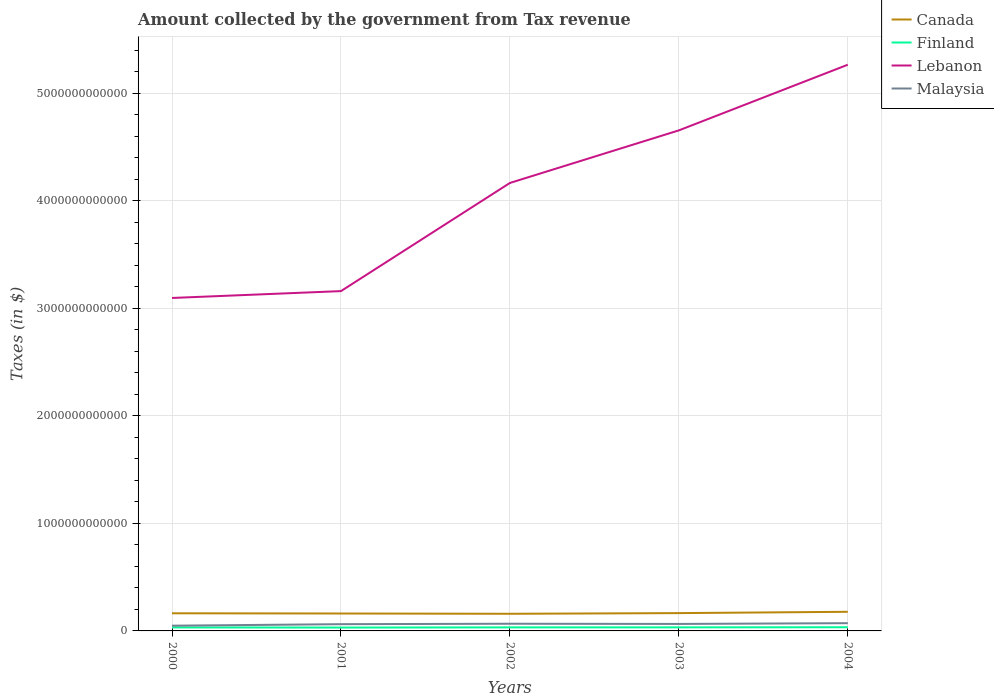Across all years, what is the maximum amount collected by the government from tax revenue in Malaysia?
Provide a succinct answer. 4.87e+1. In which year was the amount collected by the government from tax revenue in Lebanon maximum?
Provide a succinct answer. 2000. What is the total amount collected by the government from tax revenue in Malaysia in the graph?
Provide a succinct answer. -4.12e+09. What is the difference between the highest and the second highest amount collected by the government from tax revenue in Finland?
Offer a terse response. 3.12e+09. How many lines are there?
Offer a terse response. 4. What is the difference between two consecutive major ticks on the Y-axis?
Make the answer very short. 1.00e+12. Does the graph contain any zero values?
Make the answer very short. No. How many legend labels are there?
Provide a succinct answer. 4. What is the title of the graph?
Your answer should be compact. Amount collected by the government from Tax revenue. What is the label or title of the Y-axis?
Ensure brevity in your answer.  Taxes (in $). What is the Taxes (in $) in Canada in 2000?
Provide a succinct answer. 1.64e+11. What is the Taxes (in $) in Finland in 2000?
Offer a very short reply. 3.26e+1. What is the Taxes (in $) in Lebanon in 2000?
Your response must be concise. 3.10e+12. What is the Taxes (in $) in Malaysia in 2000?
Provide a succinct answer. 4.87e+1. What is the Taxes (in $) of Canada in 2001?
Keep it short and to the point. 1.62e+11. What is the Taxes (in $) of Finland in 2001?
Offer a very short reply. 3.12e+1. What is the Taxes (in $) in Lebanon in 2001?
Provide a succinct answer. 3.16e+12. What is the Taxes (in $) of Malaysia in 2001?
Offer a very short reply. 6.27e+1. What is the Taxes (in $) of Canada in 2002?
Your answer should be very brief. 1.59e+11. What is the Taxes (in $) of Finland in 2002?
Your answer should be compact. 3.30e+1. What is the Taxes (in $) in Lebanon in 2002?
Make the answer very short. 4.17e+12. What is the Taxes (in $) of Malaysia in 2002?
Your answer should be very brief. 6.69e+1. What is the Taxes (in $) of Canada in 2003?
Your answer should be very brief. 1.66e+11. What is the Taxes (in $) of Finland in 2003?
Provide a succinct answer. 3.31e+1. What is the Taxes (in $) of Lebanon in 2003?
Give a very brief answer. 4.66e+12. What is the Taxes (in $) in Malaysia in 2003?
Offer a very short reply. 6.49e+1. What is the Taxes (in $) in Canada in 2004?
Make the answer very short. 1.78e+11. What is the Taxes (in $) of Finland in 2004?
Make the answer very short. 3.43e+1. What is the Taxes (in $) of Lebanon in 2004?
Offer a very short reply. 5.27e+12. What is the Taxes (in $) in Malaysia in 2004?
Make the answer very short. 7.21e+1. Across all years, what is the maximum Taxes (in $) in Canada?
Your response must be concise. 1.78e+11. Across all years, what is the maximum Taxes (in $) in Finland?
Ensure brevity in your answer.  3.43e+1. Across all years, what is the maximum Taxes (in $) in Lebanon?
Provide a short and direct response. 5.27e+12. Across all years, what is the maximum Taxes (in $) in Malaysia?
Your answer should be very brief. 7.21e+1. Across all years, what is the minimum Taxes (in $) of Canada?
Keep it short and to the point. 1.59e+11. Across all years, what is the minimum Taxes (in $) of Finland?
Ensure brevity in your answer.  3.12e+1. Across all years, what is the minimum Taxes (in $) of Lebanon?
Provide a succinct answer. 3.10e+12. Across all years, what is the minimum Taxes (in $) in Malaysia?
Offer a very short reply. 4.87e+1. What is the total Taxes (in $) in Canada in the graph?
Your answer should be compact. 8.29e+11. What is the total Taxes (in $) in Finland in the graph?
Provide a short and direct response. 1.64e+11. What is the total Taxes (in $) in Lebanon in the graph?
Ensure brevity in your answer.  2.03e+13. What is the total Taxes (in $) in Malaysia in the graph?
Provide a short and direct response. 3.15e+11. What is the difference between the Taxes (in $) of Canada in 2000 and that in 2001?
Your response must be concise. 2.07e+09. What is the difference between the Taxes (in $) in Finland in 2000 and that in 2001?
Your answer should be compact. 1.37e+09. What is the difference between the Taxes (in $) in Lebanon in 2000 and that in 2001?
Give a very brief answer. -6.37e+1. What is the difference between the Taxes (in $) in Malaysia in 2000 and that in 2001?
Provide a succinct answer. -1.40e+1. What is the difference between the Taxes (in $) in Canada in 2000 and that in 2002?
Give a very brief answer. 4.74e+09. What is the difference between the Taxes (in $) in Finland in 2000 and that in 2002?
Your answer should be compact. -4.14e+08. What is the difference between the Taxes (in $) in Lebanon in 2000 and that in 2002?
Your answer should be very brief. -1.07e+12. What is the difference between the Taxes (in $) in Malaysia in 2000 and that in 2002?
Your answer should be compact. -1.82e+1. What is the difference between the Taxes (in $) in Canada in 2000 and that in 2003?
Your answer should be very brief. -1.55e+09. What is the difference between the Taxes (in $) in Finland in 2000 and that in 2003?
Make the answer very short. -5.11e+08. What is the difference between the Taxes (in $) of Lebanon in 2000 and that in 2003?
Make the answer very short. -1.56e+12. What is the difference between the Taxes (in $) in Malaysia in 2000 and that in 2003?
Provide a succinct answer. -1.62e+1. What is the difference between the Taxes (in $) of Canada in 2000 and that in 2004?
Your answer should be compact. -1.38e+1. What is the difference between the Taxes (in $) in Finland in 2000 and that in 2004?
Your answer should be very brief. -1.75e+09. What is the difference between the Taxes (in $) of Lebanon in 2000 and that in 2004?
Provide a succinct answer. -2.17e+12. What is the difference between the Taxes (in $) in Malaysia in 2000 and that in 2004?
Provide a succinct answer. -2.33e+1. What is the difference between the Taxes (in $) of Canada in 2001 and that in 2002?
Your answer should be very brief. 2.67e+09. What is the difference between the Taxes (in $) of Finland in 2001 and that in 2002?
Make the answer very short. -1.79e+09. What is the difference between the Taxes (in $) of Lebanon in 2001 and that in 2002?
Provide a short and direct response. -1.01e+12. What is the difference between the Taxes (in $) of Malaysia in 2001 and that in 2002?
Make the answer very short. -4.12e+09. What is the difference between the Taxes (in $) in Canada in 2001 and that in 2003?
Your answer should be compact. -3.62e+09. What is the difference between the Taxes (in $) of Finland in 2001 and that in 2003?
Offer a terse response. -1.88e+09. What is the difference between the Taxes (in $) of Lebanon in 2001 and that in 2003?
Offer a terse response. -1.49e+12. What is the difference between the Taxes (in $) in Malaysia in 2001 and that in 2003?
Your answer should be compact. -2.15e+09. What is the difference between the Taxes (in $) of Canada in 2001 and that in 2004?
Your answer should be very brief. -1.59e+1. What is the difference between the Taxes (in $) in Finland in 2001 and that in 2004?
Give a very brief answer. -3.12e+09. What is the difference between the Taxes (in $) in Lebanon in 2001 and that in 2004?
Ensure brevity in your answer.  -2.11e+12. What is the difference between the Taxes (in $) of Malaysia in 2001 and that in 2004?
Provide a short and direct response. -9.31e+09. What is the difference between the Taxes (in $) of Canada in 2002 and that in 2003?
Give a very brief answer. -6.29e+09. What is the difference between the Taxes (in $) in Finland in 2002 and that in 2003?
Provide a succinct answer. -9.70e+07. What is the difference between the Taxes (in $) in Lebanon in 2002 and that in 2003?
Your answer should be compact. -4.89e+11. What is the difference between the Taxes (in $) of Malaysia in 2002 and that in 2003?
Your answer should be compact. 1.97e+09. What is the difference between the Taxes (in $) of Canada in 2002 and that in 2004?
Give a very brief answer. -1.85e+1. What is the difference between the Taxes (in $) of Finland in 2002 and that in 2004?
Give a very brief answer. -1.34e+09. What is the difference between the Taxes (in $) in Lebanon in 2002 and that in 2004?
Keep it short and to the point. -1.10e+12. What is the difference between the Taxes (in $) of Malaysia in 2002 and that in 2004?
Give a very brief answer. -5.19e+09. What is the difference between the Taxes (in $) in Canada in 2003 and that in 2004?
Offer a very short reply. -1.22e+1. What is the difference between the Taxes (in $) of Finland in 2003 and that in 2004?
Keep it short and to the point. -1.24e+09. What is the difference between the Taxes (in $) in Lebanon in 2003 and that in 2004?
Your response must be concise. -6.11e+11. What is the difference between the Taxes (in $) of Malaysia in 2003 and that in 2004?
Your response must be concise. -7.16e+09. What is the difference between the Taxes (in $) in Canada in 2000 and the Taxes (in $) in Finland in 2001?
Offer a terse response. 1.33e+11. What is the difference between the Taxes (in $) in Canada in 2000 and the Taxes (in $) in Lebanon in 2001?
Offer a terse response. -3.00e+12. What is the difference between the Taxes (in $) in Canada in 2000 and the Taxes (in $) in Malaysia in 2001?
Offer a very short reply. 1.01e+11. What is the difference between the Taxes (in $) of Finland in 2000 and the Taxes (in $) of Lebanon in 2001?
Offer a very short reply. -3.13e+12. What is the difference between the Taxes (in $) of Finland in 2000 and the Taxes (in $) of Malaysia in 2001?
Your answer should be very brief. -3.02e+1. What is the difference between the Taxes (in $) in Lebanon in 2000 and the Taxes (in $) in Malaysia in 2001?
Provide a succinct answer. 3.03e+12. What is the difference between the Taxes (in $) of Canada in 2000 and the Taxes (in $) of Finland in 2002?
Provide a short and direct response. 1.31e+11. What is the difference between the Taxes (in $) of Canada in 2000 and the Taxes (in $) of Lebanon in 2002?
Provide a short and direct response. -4.00e+12. What is the difference between the Taxes (in $) of Canada in 2000 and the Taxes (in $) of Malaysia in 2002?
Offer a very short reply. 9.72e+1. What is the difference between the Taxes (in $) in Finland in 2000 and the Taxes (in $) in Lebanon in 2002?
Your answer should be compact. -4.13e+12. What is the difference between the Taxes (in $) in Finland in 2000 and the Taxes (in $) in Malaysia in 2002?
Your answer should be compact. -3.43e+1. What is the difference between the Taxes (in $) of Lebanon in 2000 and the Taxes (in $) of Malaysia in 2002?
Offer a terse response. 3.03e+12. What is the difference between the Taxes (in $) in Canada in 2000 and the Taxes (in $) in Finland in 2003?
Offer a very short reply. 1.31e+11. What is the difference between the Taxes (in $) of Canada in 2000 and the Taxes (in $) of Lebanon in 2003?
Make the answer very short. -4.49e+12. What is the difference between the Taxes (in $) of Canada in 2000 and the Taxes (in $) of Malaysia in 2003?
Offer a terse response. 9.92e+1. What is the difference between the Taxes (in $) in Finland in 2000 and the Taxes (in $) in Lebanon in 2003?
Offer a very short reply. -4.62e+12. What is the difference between the Taxes (in $) in Finland in 2000 and the Taxes (in $) in Malaysia in 2003?
Your answer should be compact. -3.23e+1. What is the difference between the Taxes (in $) in Lebanon in 2000 and the Taxes (in $) in Malaysia in 2003?
Offer a very short reply. 3.03e+12. What is the difference between the Taxes (in $) in Canada in 2000 and the Taxes (in $) in Finland in 2004?
Your response must be concise. 1.30e+11. What is the difference between the Taxes (in $) in Canada in 2000 and the Taxes (in $) in Lebanon in 2004?
Give a very brief answer. -5.10e+12. What is the difference between the Taxes (in $) of Canada in 2000 and the Taxes (in $) of Malaysia in 2004?
Offer a terse response. 9.20e+1. What is the difference between the Taxes (in $) in Finland in 2000 and the Taxes (in $) in Lebanon in 2004?
Keep it short and to the point. -5.23e+12. What is the difference between the Taxes (in $) in Finland in 2000 and the Taxes (in $) in Malaysia in 2004?
Provide a short and direct response. -3.95e+1. What is the difference between the Taxes (in $) of Lebanon in 2000 and the Taxes (in $) of Malaysia in 2004?
Keep it short and to the point. 3.02e+12. What is the difference between the Taxes (in $) of Canada in 2001 and the Taxes (in $) of Finland in 2002?
Provide a short and direct response. 1.29e+11. What is the difference between the Taxes (in $) in Canada in 2001 and the Taxes (in $) in Lebanon in 2002?
Your answer should be compact. -4.00e+12. What is the difference between the Taxes (in $) in Canada in 2001 and the Taxes (in $) in Malaysia in 2002?
Offer a terse response. 9.52e+1. What is the difference between the Taxes (in $) of Finland in 2001 and the Taxes (in $) of Lebanon in 2002?
Your answer should be very brief. -4.14e+12. What is the difference between the Taxes (in $) of Finland in 2001 and the Taxes (in $) of Malaysia in 2002?
Your answer should be compact. -3.56e+1. What is the difference between the Taxes (in $) of Lebanon in 2001 and the Taxes (in $) of Malaysia in 2002?
Ensure brevity in your answer.  3.09e+12. What is the difference between the Taxes (in $) of Canada in 2001 and the Taxes (in $) of Finland in 2003?
Keep it short and to the point. 1.29e+11. What is the difference between the Taxes (in $) in Canada in 2001 and the Taxes (in $) in Lebanon in 2003?
Make the answer very short. -4.49e+12. What is the difference between the Taxes (in $) in Canada in 2001 and the Taxes (in $) in Malaysia in 2003?
Keep it short and to the point. 9.71e+1. What is the difference between the Taxes (in $) of Finland in 2001 and the Taxes (in $) of Lebanon in 2003?
Make the answer very short. -4.62e+12. What is the difference between the Taxes (in $) in Finland in 2001 and the Taxes (in $) in Malaysia in 2003?
Give a very brief answer. -3.37e+1. What is the difference between the Taxes (in $) of Lebanon in 2001 and the Taxes (in $) of Malaysia in 2003?
Offer a very short reply. 3.10e+12. What is the difference between the Taxes (in $) of Canada in 2001 and the Taxes (in $) of Finland in 2004?
Make the answer very short. 1.28e+11. What is the difference between the Taxes (in $) of Canada in 2001 and the Taxes (in $) of Lebanon in 2004?
Ensure brevity in your answer.  -5.10e+12. What is the difference between the Taxes (in $) in Canada in 2001 and the Taxes (in $) in Malaysia in 2004?
Your answer should be very brief. 9.00e+1. What is the difference between the Taxes (in $) in Finland in 2001 and the Taxes (in $) in Lebanon in 2004?
Offer a terse response. -5.23e+12. What is the difference between the Taxes (in $) of Finland in 2001 and the Taxes (in $) of Malaysia in 2004?
Provide a succinct answer. -4.08e+1. What is the difference between the Taxes (in $) in Lebanon in 2001 and the Taxes (in $) in Malaysia in 2004?
Your answer should be very brief. 3.09e+12. What is the difference between the Taxes (in $) in Canada in 2002 and the Taxes (in $) in Finland in 2003?
Offer a very short reply. 1.26e+11. What is the difference between the Taxes (in $) of Canada in 2002 and the Taxes (in $) of Lebanon in 2003?
Keep it short and to the point. -4.50e+12. What is the difference between the Taxes (in $) of Canada in 2002 and the Taxes (in $) of Malaysia in 2003?
Provide a succinct answer. 9.45e+1. What is the difference between the Taxes (in $) of Finland in 2002 and the Taxes (in $) of Lebanon in 2003?
Your answer should be very brief. -4.62e+12. What is the difference between the Taxes (in $) in Finland in 2002 and the Taxes (in $) in Malaysia in 2003?
Keep it short and to the point. -3.19e+1. What is the difference between the Taxes (in $) in Lebanon in 2002 and the Taxes (in $) in Malaysia in 2003?
Keep it short and to the point. 4.10e+12. What is the difference between the Taxes (in $) in Canada in 2002 and the Taxes (in $) in Finland in 2004?
Provide a succinct answer. 1.25e+11. What is the difference between the Taxes (in $) in Canada in 2002 and the Taxes (in $) in Lebanon in 2004?
Offer a terse response. -5.11e+12. What is the difference between the Taxes (in $) in Canada in 2002 and the Taxes (in $) in Malaysia in 2004?
Provide a short and direct response. 8.73e+1. What is the difference between the Taxes (in $) of Finland in 2002 and the Taxes (in $) of Lebanon in 2004?
Make the answer very short. -5.23e+12. What is the difference between the Taxes (in $) of Finland in 2002 and the Taxes (in $) of Malaysia in 2004?
Your answer should be compact. -3.91e+1. What is the difference between the Taxes (in $) in Lebanon in 2002 and the Taxes (in $) in Malaysia in 2004?
Provide a short and direct response. 4.09e+12. What is the difference between the Taxes (in $) in Canada in 2003 and the Taxes (in $) in Finland in 2004?
Offer a terse response. 1.31e+11. What is the difference between the Taxes (in $) of Canada in 2003 and the Taxes (in $) of Lebanon in 2004?
Provide a succinct answer. -5.10e+12. What is the difference between the Taxes (in $) of Canada in 2003 and the Taxes (in $) of Malaysia in 2004?
Offer a terse response. 9.36e+1. What is the difference between the Taxes (in $) of Finland in 2003 and the Taxes (in $) of Lebanon in 2004?
Offer a very short reply. -5.23e+12. What is the difference between the Taxes (in $) of Finland in 2003 and the Taxes (in $) of Malaysia in 2004?
Your response must be concise. -3.90e+1. What is the difference between the Taxes (in $) in Lebanon in 2003 and the Taxes (in $) in Malaysia in 2004?
Your answer should be very brief. 4.58e+12. What is the average Taxes (in $) of Canada per year?
Your answer should be compact. 1.66e+11. What is the average Taxes (in $) in Finland per year?
Give a very brief answer. 3.28e+1. What is the average Taxes (in $) of Lebanon per year?
Provide a short and direct response. 4.07e+12. What is the average Taxes (in $) in Malaysia per year?
Your answer should be very brief. 6.31e+1. In the year 2000, what is the difference between the Taxes (in $) in Canada and Taxes (in $) in Finland?
Your response must be concise. 1.32e+11. In the year 2000, what is the difference between the Taxes (in $) of Canada and Taxes (in $) of Lebanon?
Provide a short and direct response. -2.93e+12. In the year 2000, what is the difference between the Taxes (in $) of Canada and Taxes (in $) of Malaysia?
Provide a succinct answer. 1.15e+11. In the year 2000, what is the difference between the Taxes (in $) in Finland and Taxes (in $) in Lebanon?
Give a very brief answer. -3.06e+12. In the year 2000, what is the difference between the Taxes (in $) of Finland and Taxes (in $) of Malaysia?
Your answer should be very brief. -1.61e+1. In the year 2000, what is the difference between the Taxes (in $) in Lebanon and Taxes (in $) in Malaysia?
Ensure brevity in your answer.  3.05e+12. In the year 2001, what is the difference between the Taxes (in $) in Canada and Taxes (in $) in Finland?
Your answer should be very brief. 1.31e+11. In the year 2001, what is the difference between the Taxes (in $) in Canada and Taxes (in $) in Lebanon?
Your answer should be very brief. -3.00e+12. In the year 2001, what is the difference between the Taxes (in $) in Canada and Taxes (in $) in Malaysia?
Your answer should be very brief. 9.93e+1. In the year 2001, what is the difference between the Taxes (in $) of Finland and Taxes (in $) of Lebanon?
Your answer should be compact. -3.13e+12. In the year 2001, what is the difference between the Taxes (in $) in Finland and Taxes (in $) in Malaysia?
Provide a succinct answer. -3.15e+1. In the year 2001, what is the difference between the Taxes (in $) of Lebanon and Taxes (in $) of Malaysia?
Provide a succinct answer. 3.10e+12. In the year 2002, what is the difference between the Taxes (in $) in Canada and Taxes (in $) in Finland?
Keep it short and to the point. 1.26e+11. In the year 2002, what is the difference between the Taxes (in $) in Canada and Taxes (in $) in Lebanon?
Offer a terse response. -4.01e+12. In the year 2002, what is the difference between the Taxes (in $) of Canada and Taxes (in $) of Malaysia?
Provide a succinct answer. 9.25e+1. In the year 2002, what is the difference between the Taxes (in $) in Finland and Taxes (in $) in Lebanon?
Provide a short and direct response. -4.13e+12. In the year 2002, what is the difference between the Taxes (in $) of Finland and Taxes (in $) of Malaysia?
Your answer should be compact. -3.39e+1. In the year 2002, what is the difference between the Taxes (in $) of Lebanon and Taxes (in $) of Malaysia?
Provide a short and direct response. 4.10e+12. In the year 2003, what is the difference between the Taxes (in $) in Canada and Taxes (in $) in Finland?
Provide a succinct answer. 1.33e+11. In the year 2003, what is the difference between the Taxes (in $) in Canada and Taxes (in $) in Lebanon?
Provide a succinct answer. -4.49e+12. In the year 2003, what is the difference between the Taxes (in $) of Canada and Taxes (in $) of Malaysia?
Give a very brief answer. 1.01e+11. In the year 2003, what is the difference between the Taxes (in $) of Finland and Taxes (in $) of Lebanon?
Offer a terse response. -4.62e+12. In the year 2003, what is the difference between the Taxes (in $) in Finland and Taxes (in $) in Malaysia?
Offer a terse response. -3.18e+1. In the year 2003, what is the difference between the Taxes (in $) in Lebanon and Taxes (in $) in Malaysia?
Give a very brief answer. 4.59e+12. In the year 2004, what is the difference between the Taxes (in $) in Canada and Taxes (in $) in Finland?
Offer a very short reply. 1.44e+11. In the year 2004, what is the difference between the Taxes (in $) in Canada and Taxes (in $) in Lebanon?
Provide a short and direct response. -5.09e+12. In the year 2004, what is the difference between the Taxes (in $) in Canada and Taxes (in $) in Malaysia?
Offer a very short reply. 1.06e+11. In the year 2004, what is the difference between the Taxes (in $) in Finland and Taxes (in $) in Lebanon?
Give a very brief answer. -5.23e+12. In the year 2004, what is the difference between the Taxes (in $) in Finland and Taxes (in $) in Malaysia?
Keep it short and to the point. -3.77e+1. In the year 2004, what is the difference between the Taxes (in $) in Lebanon and Taxes (in $) in Malaysia?
Offer a terse response. 5.19e+12. What is the ratio of the Taxes (in $) of Canada in 2000 to that in 2001?
Give a very brief answer. 1.01. What is the ratio of the Taxes (in $) in Finland in 2000 to that in 2001?
Keep it short and to the point. 1.04. What is the ratio of the Taxes (in $) in Lebanon in 2000 to that in 2001?
Keep it short and to the point. 0.98. What is the ratio of the Taxes (in $) in Malaysia in 2000 to that in 2001?
Offer a terse response. 0.78. What is the ratio of the Taxes (in $) of Canada in 2000 to that in 2002?
Your answer should be very brief. 1.03. What is the ratio of the Taxes (in $) in Finland in 2000 to that in 2002?
Your answer should be compact. 0.99. What is the ratio of the Taxes (in $) of Lebanon in 2000 to that in 2002?
Offer a very short reply. 0.74. What is the ratio of the Taxes (in $) of Malaysia in 2000 to that in 2002?
Keep it short and to the point. 0.73. What is the ratio of the Taxes (in $) of Canada in 2000 to that in 2003?
Keep it short and to the point. 0.99. What is the ratio of the Taxes (in $) in Finland in 2000 to that in 2003?
Offer a very short reply. 0.98. What is the ratio of the Taxes (in $) of Lebanon in 2000 to that in 2003?
Make the answer very short. 0.67. What is the ratio of the Taxes (in $) in Malaysia in 2000 to that in 2003?
Make the answer very short. 0.75. What is the ratio of the Taxes (in $) of Canada in 2000 to that in 2004?
Your answer should be very brief. 0.92. What is the ratio of the Taxes (in $) of Finland in 2000 to that in 2004?
Provide a succinct answer. 0.95. What is the ratio of the Taxes (in $) of Lebanon in 2000 to that in 2004?
Your answer should be very brief. 0.59. What is the ratio of the Taxes (in $) in Malaysia in 2000 to that in 2004?
Make the answer very short. 0.68. What is the ratio of the Taxes (in $) in Canada in 2001 to that in 2002?
Ensure brevity in your answer.  1.02. What is the ratio of the Taxes (in $) in Finland in 2001 to that in 2002?
Your answer should be compact. 0.95. What is the ratio of the Taxes (in $) of Lebanon in 2001 to that in 2002?
Keep it short and to the point. 0.76. What is the ratio of the Taxes (in $) in Malaysia in 2001 to that in 2002?
Make the answer very short. 0.94. What is the ratio of the Taxes (in $) of Canada in 2001 to that in 2003?
Your answer should be very brief. 0.98. What is the ratio of the Taxes (in $) in Finland in 2001 to that in 2003?
Your answer should be very brief. 0.94. What is the ratio of the Taxes (in $) of Lebanon in 2001 to that in 2003?
Offer a very short reply. 0.68. What is the ratio of the Taxes (in $) in Malaysia in 2001 to that in 2003?
Provide a succinct answer. 0.97. What is the ratio of the Taxes (in $) in Canada in 2001 to that in 2004?
Offer a very short reply. 0.91. What is the ratio of the Taxes (in $) in Finland in 2001 to that in 2004?
Make the answer very short. 0.91. What is the ratio of the Taxes (in $) of Lebanon in 2001 to that in 2004?
Provide a short and direct response. 0.6. What is the ratio of the Taxes (in $) in Malaysia in 2001 to that in 2004?
Ensure brevity in your answer.  0.87. What is the ratio of the Taxes (in $) in Canada in 2002 to that in 2003?
Your answer should be compact. 0.96. What is the ratio of the Taxes (in $) in Lebanon in 2002 to that in 2003?
Provide a succinct answer. 0.9. What is the ratio of the Taxes (in $) in Malaysia in 2002 to that in 2003?
Provide a short and direct response. 1.03. What is the ratio of the Taxes (in $) of Canada in 2002 to that in 2004?
Offer a very short reply. 0.9. What is the ratio of the Taxes (in $) in Lebanon in 2002 to that in 2004?
Offer a terse response. 0.79. What is the ratio of the Taxes (in $) of Malaysia in 2002 to that in 2004?
Make the answer very short. 0.93. What is the ratio of the Taxes (in $) in Canada in 2003 to that in 2004?
Give a very brief answer. 0.93. What is the ratio of the Taxes (in $) in Finland in 2003 to that in 2004?
Give a very brief answer. 0.96. What is the ratio of the Taxes (in $) in Lebanon in 2003 to that in 2004?
Offer a very short reply. 0.88. What is the ratio of the Taxes (in $) in Malaysia in 2003 to that in 2004?
Your response must be concise. 0.9. What is the difference between the highest and the second highest Taxes (in $) in Canada?
Offer a terse response. 1.22e+1. What is the difference between the highest and the second highest Taxes (in $) of Finland?
Give a very brief answer. 1.24e+09. What is the difference between the highest and the second highest Taxes (in $) in Lebanon?
Provide a succinct answer. 6.11e+11. What is the difference between the highest and the second highest Taxes (in $) of Malaysia?
Your answer should be very brief. 5.19e+09. What is the difference between the highest and the lowest Taxes (in $) in Canada?
Provide a short and direct response. 1.85e+1. What is the difference between the highest and the lowest Taxes (in $) of Finland?
Keep it short and to the point. 3.12e+09. What is the difference between the highest and the lowest Taxes (in $) of Lebanon?
Make the answer very short. 2.17e+12. What is the difference between the highest and the lowest Taxes (in $) of Malaysia?
Keep it short and to the point. 2.33e+1. 